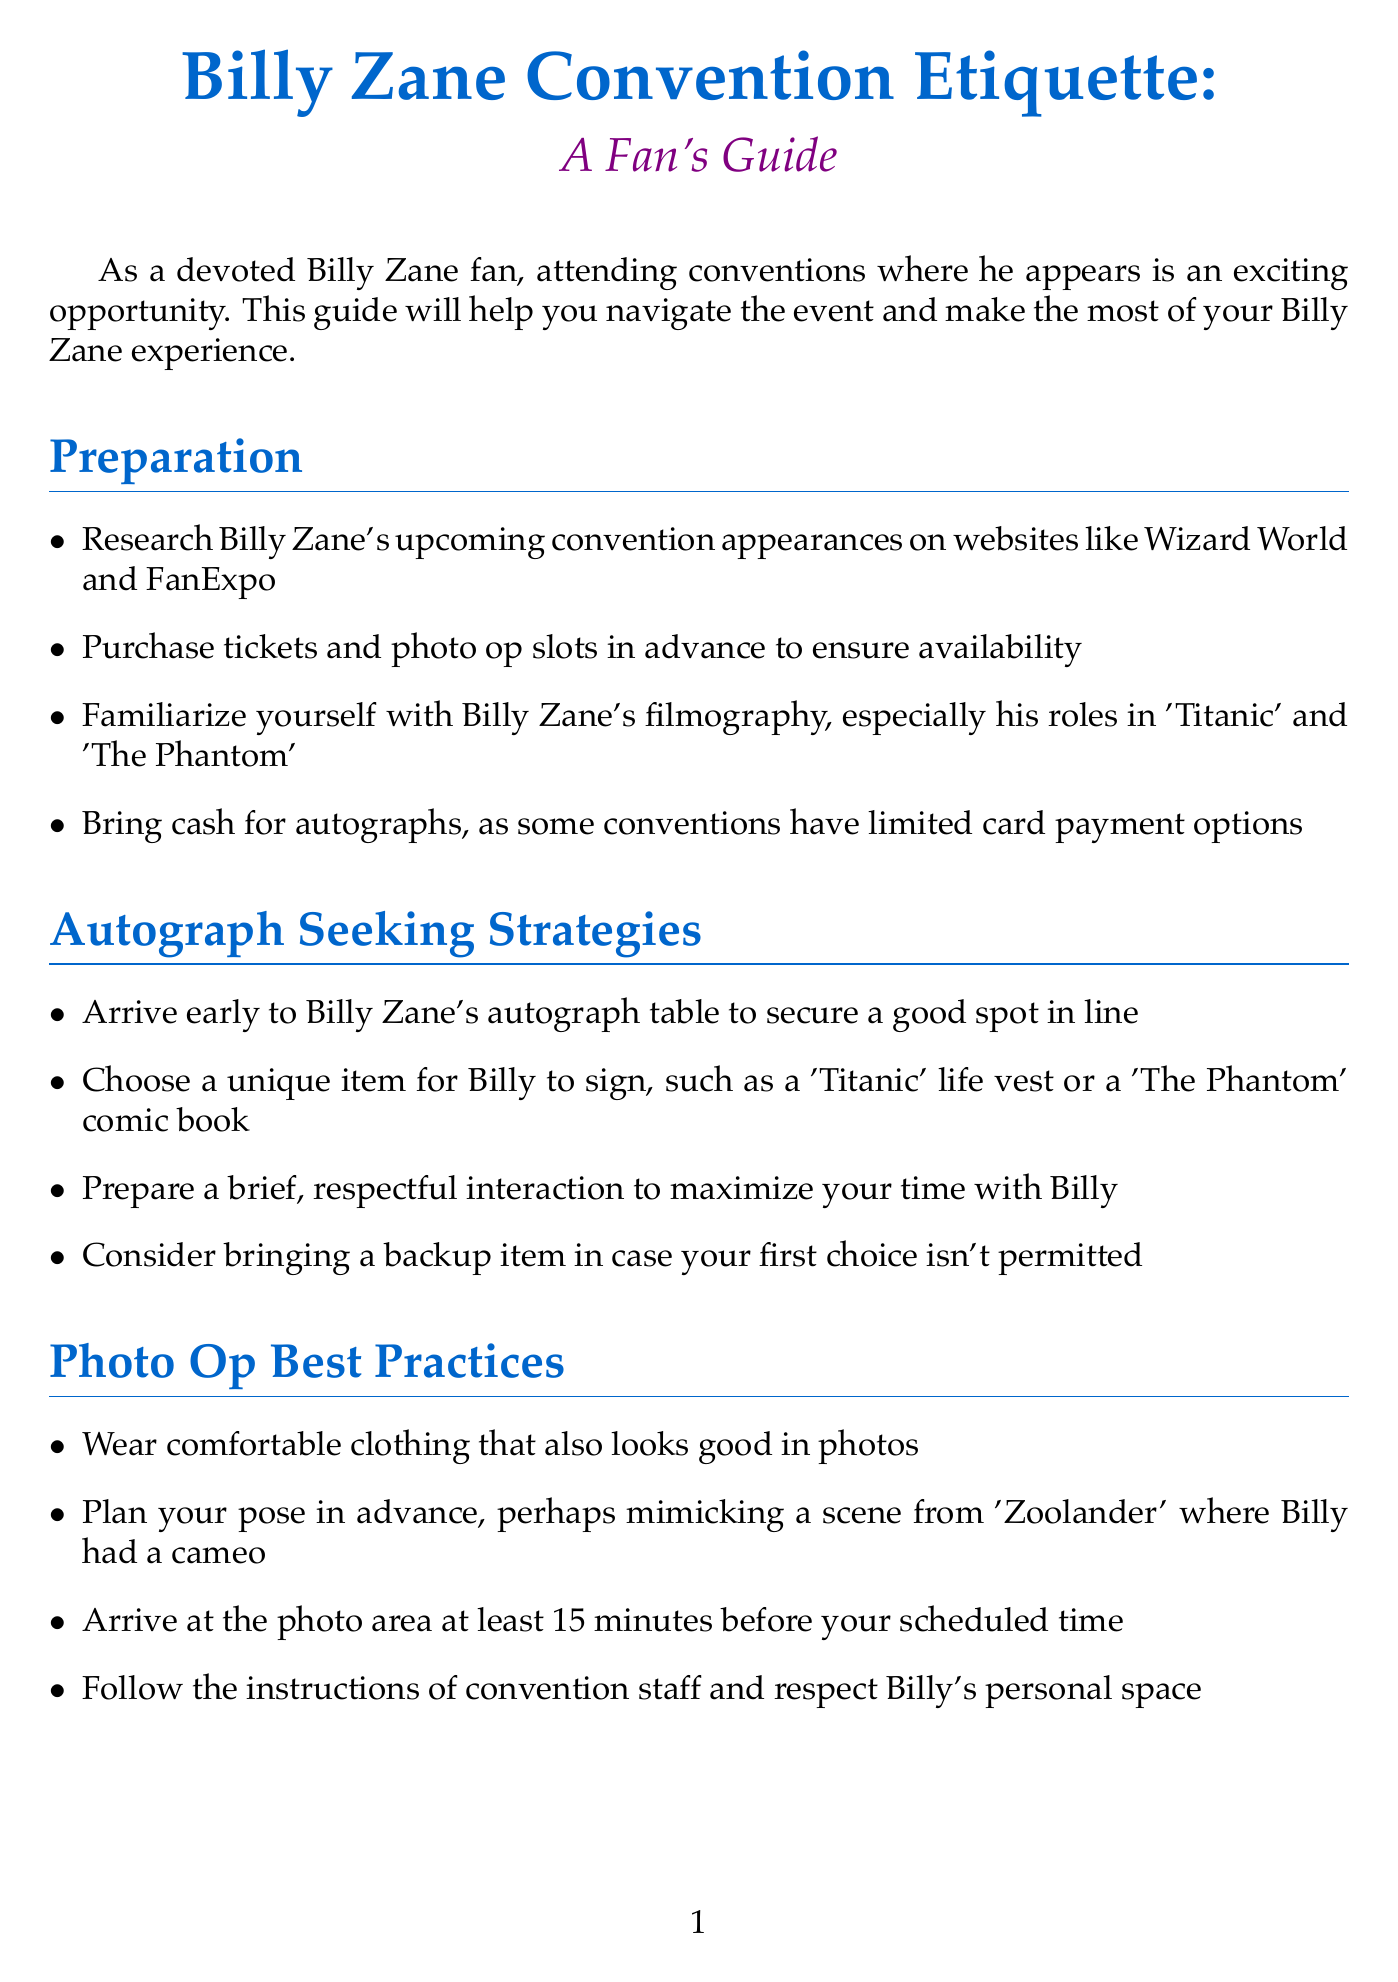What is the title of the guide? The title of the guide is found in the introduction section.
Answer: Billy Zane Convention Etiquette: A Fan's Guide How should fans prepare for conventions? Fans should follow the preparation steps listed in the document, including researching appearances and familiarizing themselves with his filmography.
Answer: Research Billy Zane's upcoming convention appearances What is a recommended item to get autographed? The document suggests unique items that fans might want to have signed by Billy Zane.
Answer: Titanic life vest How long should you arrive before a photo op? The document specifies a time frame for arriving at the photo area.
Answer: 15 minutes What should you avoid asking during the Q&A panel? The document provides guidance on appropriate questions for the panel.
Answer: Overly personal questions What is one way to network with other fans? The document lists strategies for interacting with fellow fans.
Answer: Join Billy Zane fan groups on social media What is suggested for displaying autographed items? The document recommends proper care for autographed items after the convention.
Answer: Properly store and display your autographed items What is a key aspect of the fan experience according to the conclusion? The conclusion emphasizes an important sentiment for fans attending conventions.
Answer: Be respectful, have fun What should fans do after sharing their experience on social media? The document discusses what to do following social media engagement.
Answer: Start planning for your next Billy Zane convention appearance 